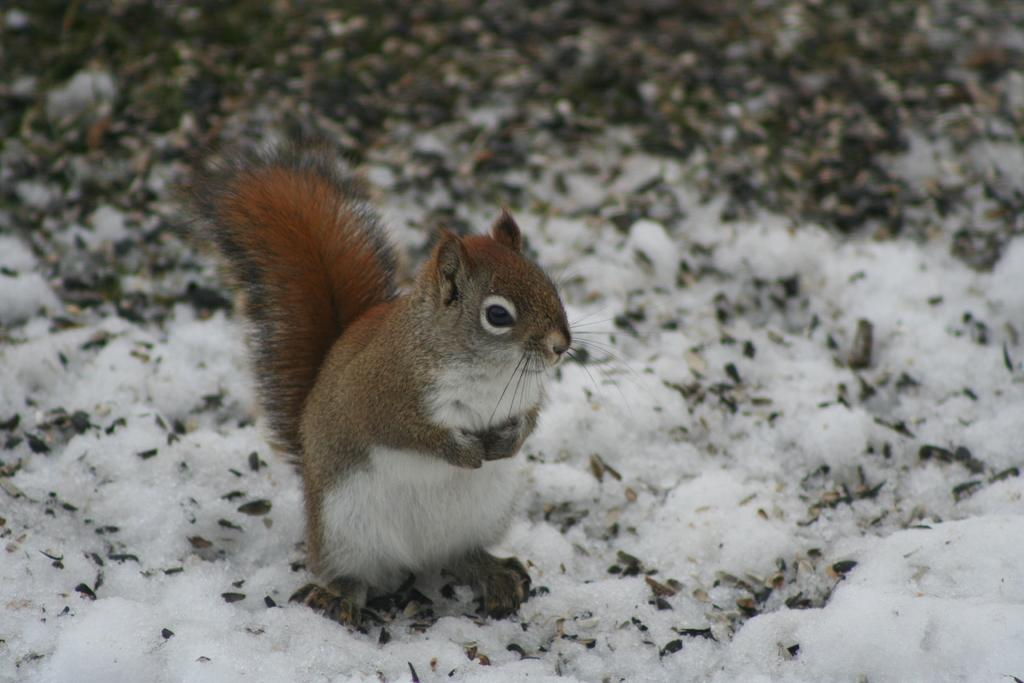What animal can be seen in the picture? There is a squirrel in the picture. What type of weather is depicted in the picture? There is snow in the picture. Can you describe the background of the picture? The background of the picture is blurry. What type of pancake is the squirrel holding in the picture? There is no pancake present in the picture; it features a squirrel in the snow. 